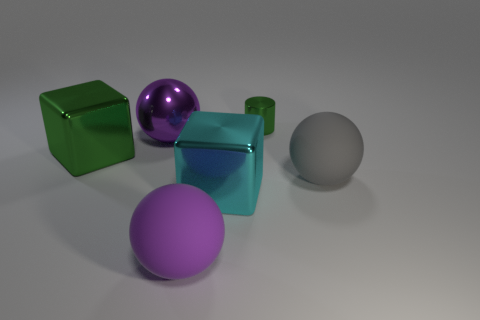Subtract all big metallic balls. How many balls are left? 2 Add 3 large purple objects. How many objects exist? 9 Subtract all green cubes. How many cubes are left? 1 Subtract all cylinders. How many objects are left? 5 Subtract 1 spheres. How many spheres are left? 2 Subtract all brown cubes. How many red cylinders are left? 0 Subtract all tiny green rubber cylinders. Subtract all large rubber spheres. How many objects are left? 4 Add 2 small green metallic things. How many small green metallic things are left? 3 Add 5 metal cylinders. How many metal cylinders exist? 6 Subtract 0 yellow cylinders. How many objects are left? 6 